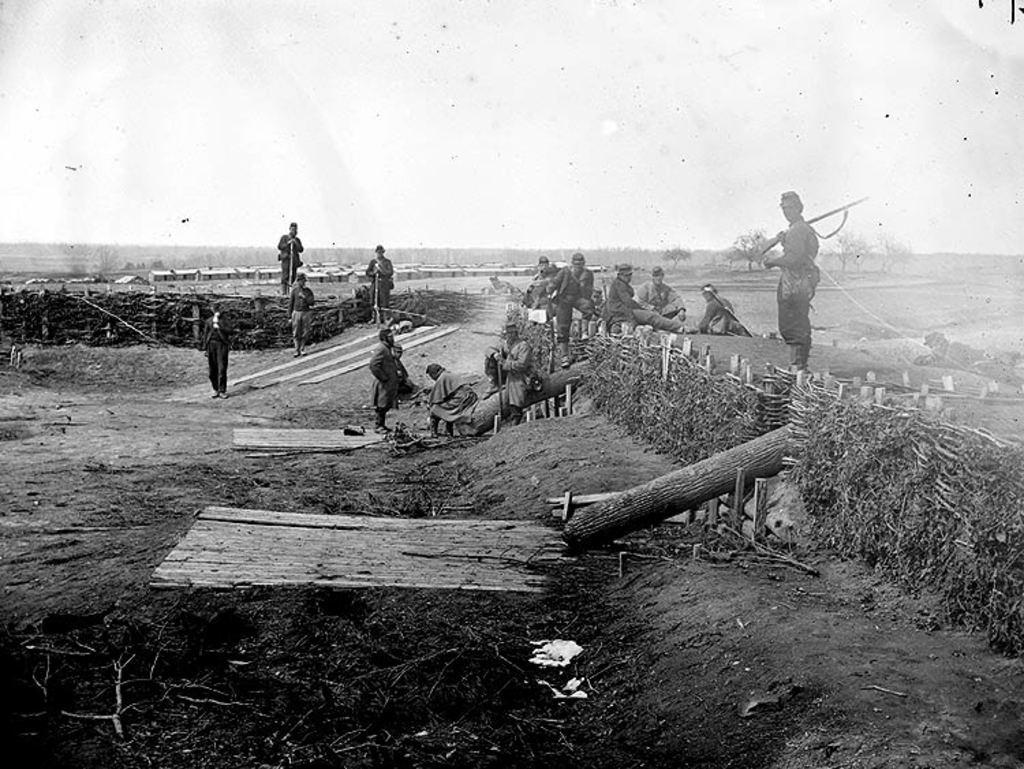Please provide a concise description of this image. This is a black and white image. In this image we can see people standing on the round and holding guns in their hands and some are sitting on the ground. In addition to this we can see trees, sky, wooden fences and wooden planks on the ground. 